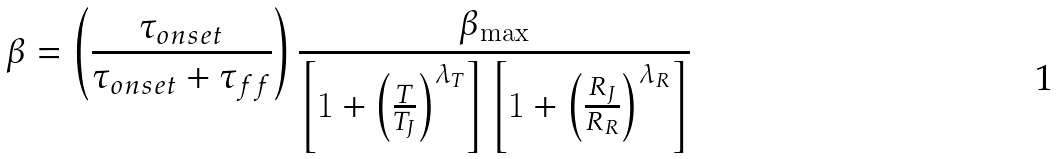<formula> <loc_0><loc_0><loc_500><loc_500>\beta = \left ( \frac { \tau _ { o n s e t } } { \tau _ { o n s e t } + \tau _ { f f } } \right ) \frac { \beta _ { \max } } { \left [ 1 + \left ( \frac { T } { T _ { J } } \right ) ^ { \lambda _ { T } } \right ] \left [ 1 + \left ( \frac { R _ { J } } { R _ { R } } \right ) ^ { \lambda _ { R } } \right ] }</formula> 